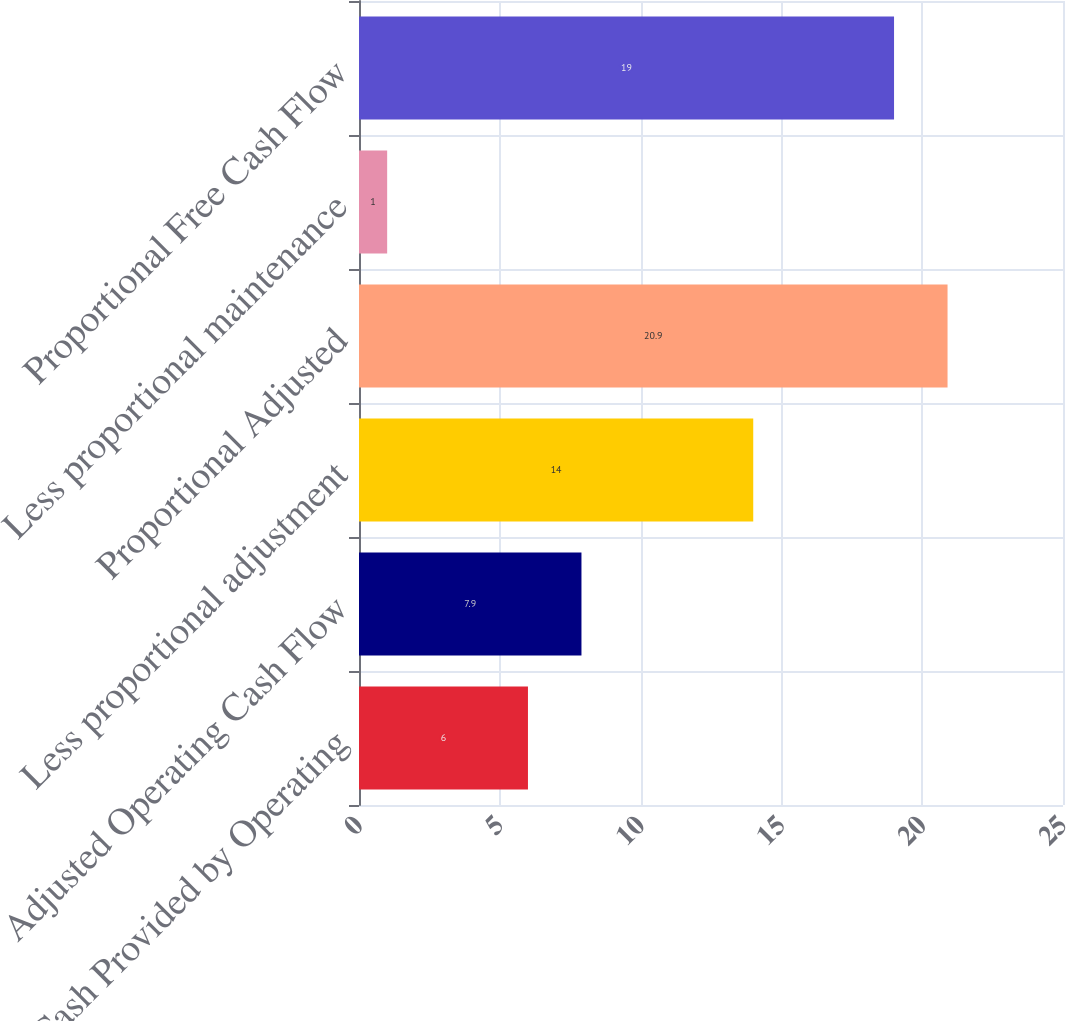<chart> <loc_0><loc_0><loc_500><loc_500><bar_chart><fcel>Net Cash Provided by Operating<fcel>Adjusted Operating Cash Flow<fcel>Less proportional adjustment<fcel>Proportional Adjusted<fcel>Less proportional maintenance<fcel>Proportional Free Cash Flow<nl><fcel>6<fcel>7.9<fcel>14<fcel>20.9<fcel>1<fcel>19<nl></chart> 